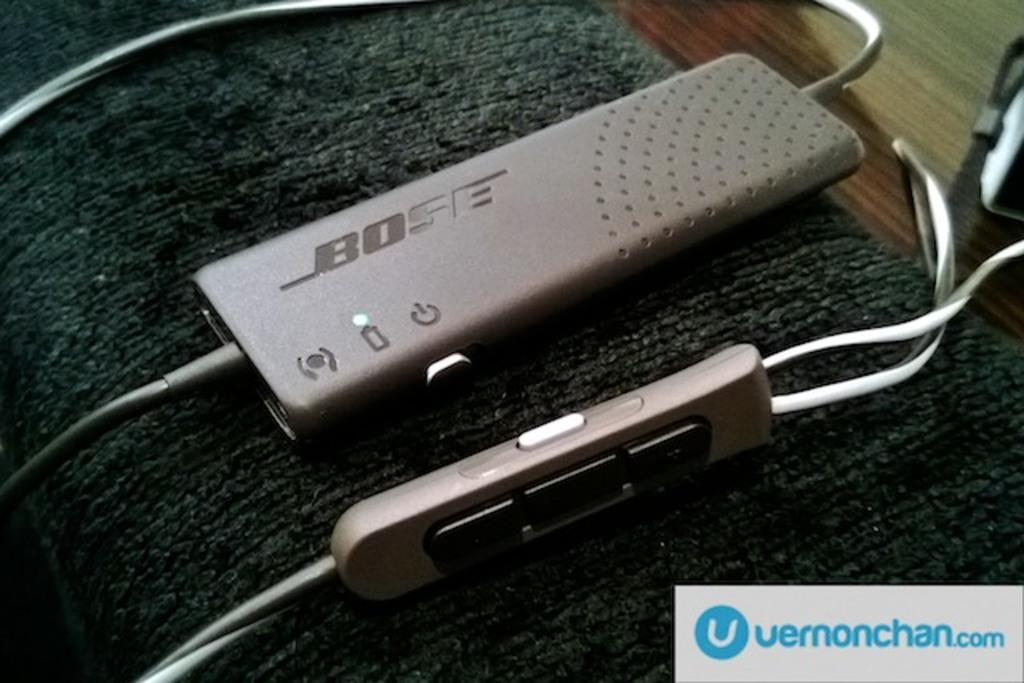<image>
Provide a brief description of the given image. A device is shown with a website, vernonchan.com, in the corner. 